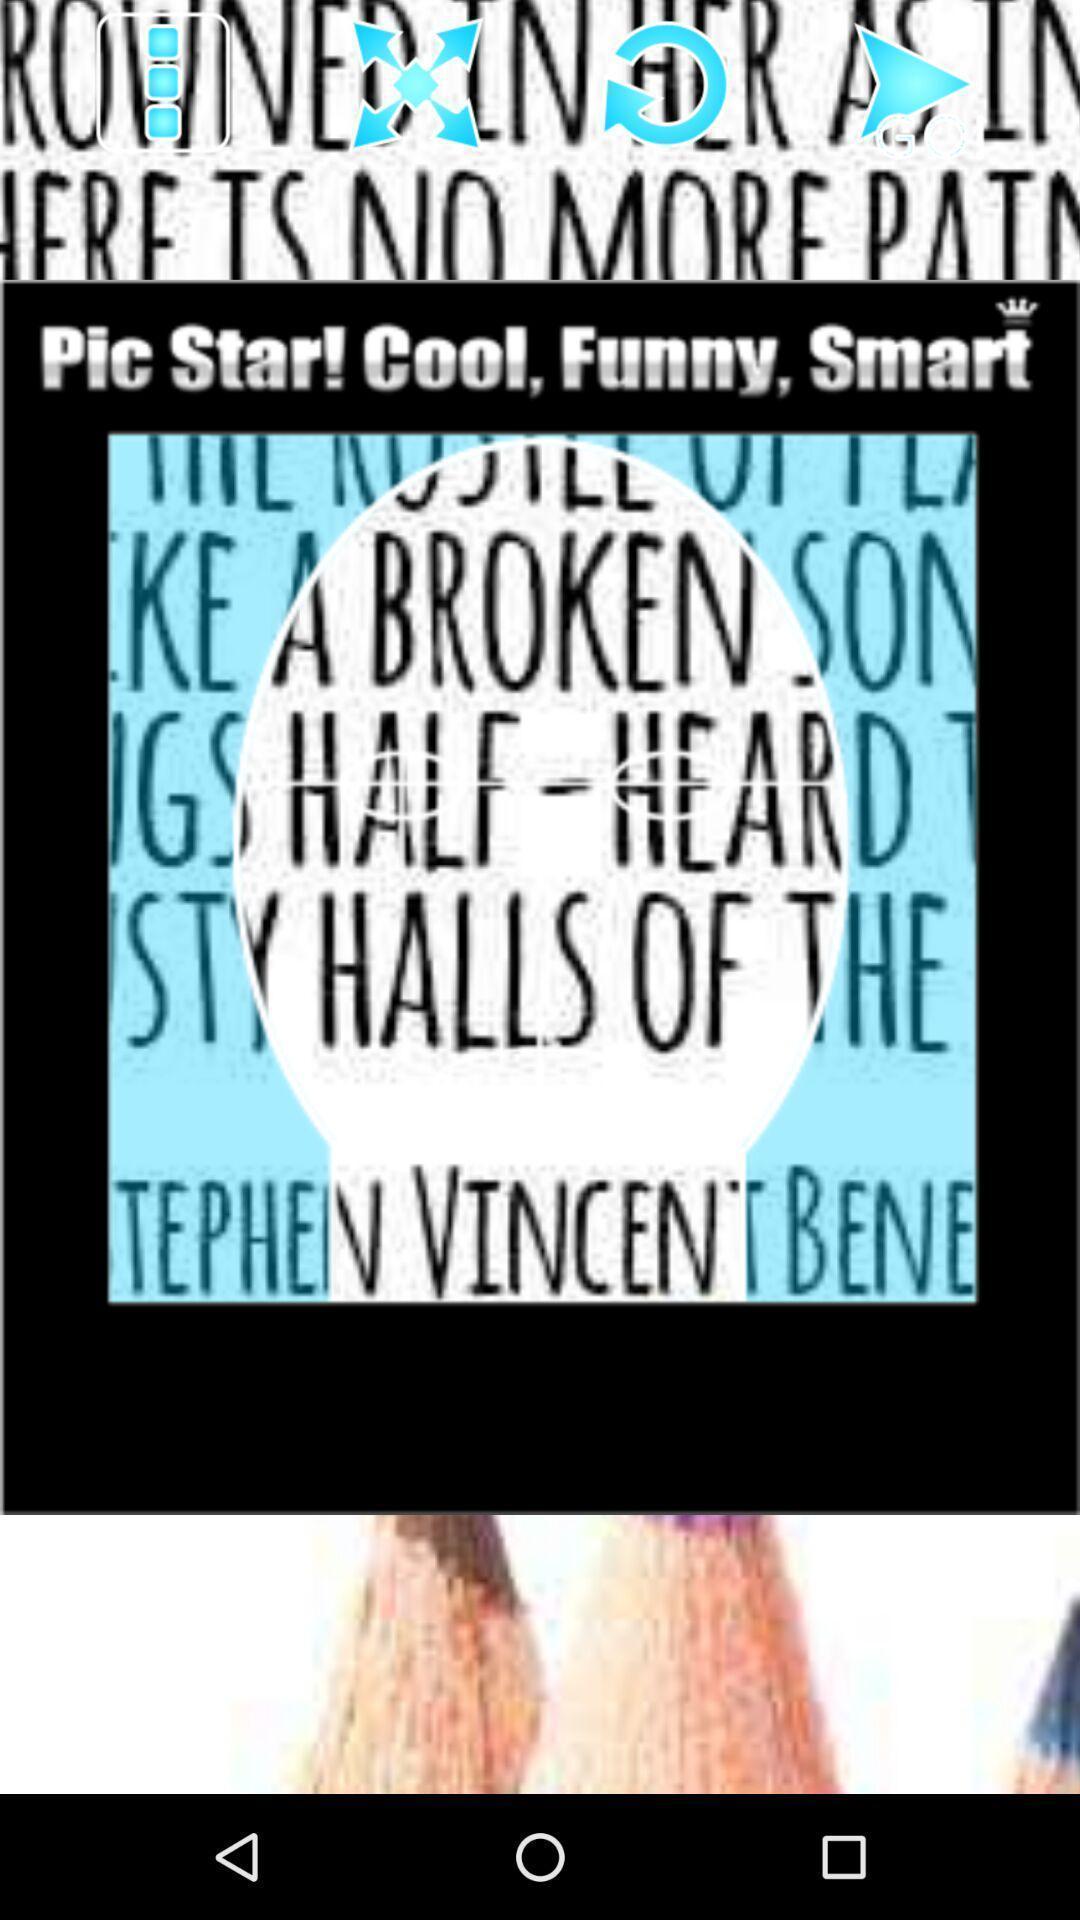What is the overall content of this screenshot? Screen showing the image slide show. 